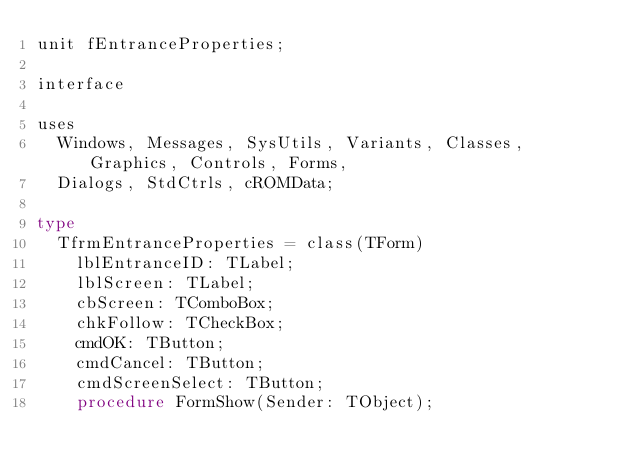<code> <loc_0><loc_0><loc_500><loc_500><_Pascal_>unit fEntranceProperties;

interface

uses
  Windows, Messages, SysUtils, Variants, Classes, Graphics, Controls, Forms,
  Dialogs, StdCtrls, cROMData;

type
  TfrmEntranceProperties = class(TForm)
    lblEntranceID: TLabel;
    lblScreen: TLabel;
    cbScreen: TComboBox;
    chkFollow: TCheckBox;
    cmdOK: TButton;
    cmdCancel: TButton;
    cmdScreenSelect: TButton;
    procedure FormShow(Sender: TObject);</code> 